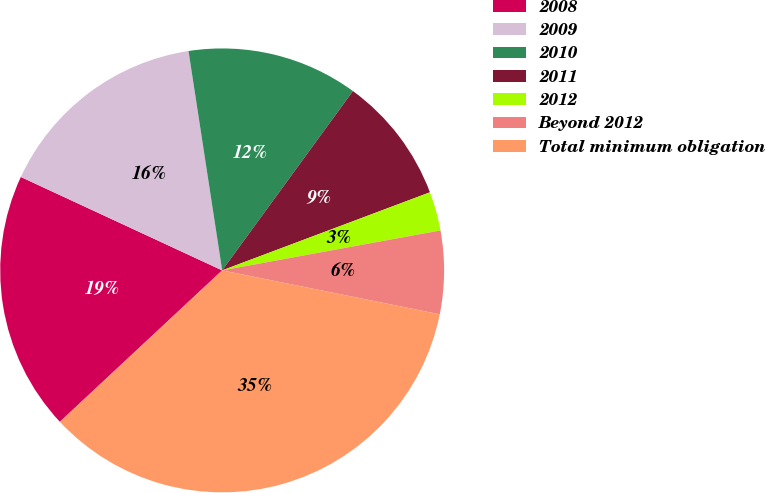Convert chart to OTSL. <chart><loc_0><loc_0><loc_500><loc_500><pie_chart><fcel>2008<fcel>2009<fcel>2010<fcel>2011<fcel>2012<fcel>Beyond 2012<fcel>Total minimum obligation<nl><fcel>18.86%<fcel>15.66%<fcel>12.45%<fcel>9.25%<fcel>2.84%<fcel>6.05%<fcel>34.88%<nl></chart> 